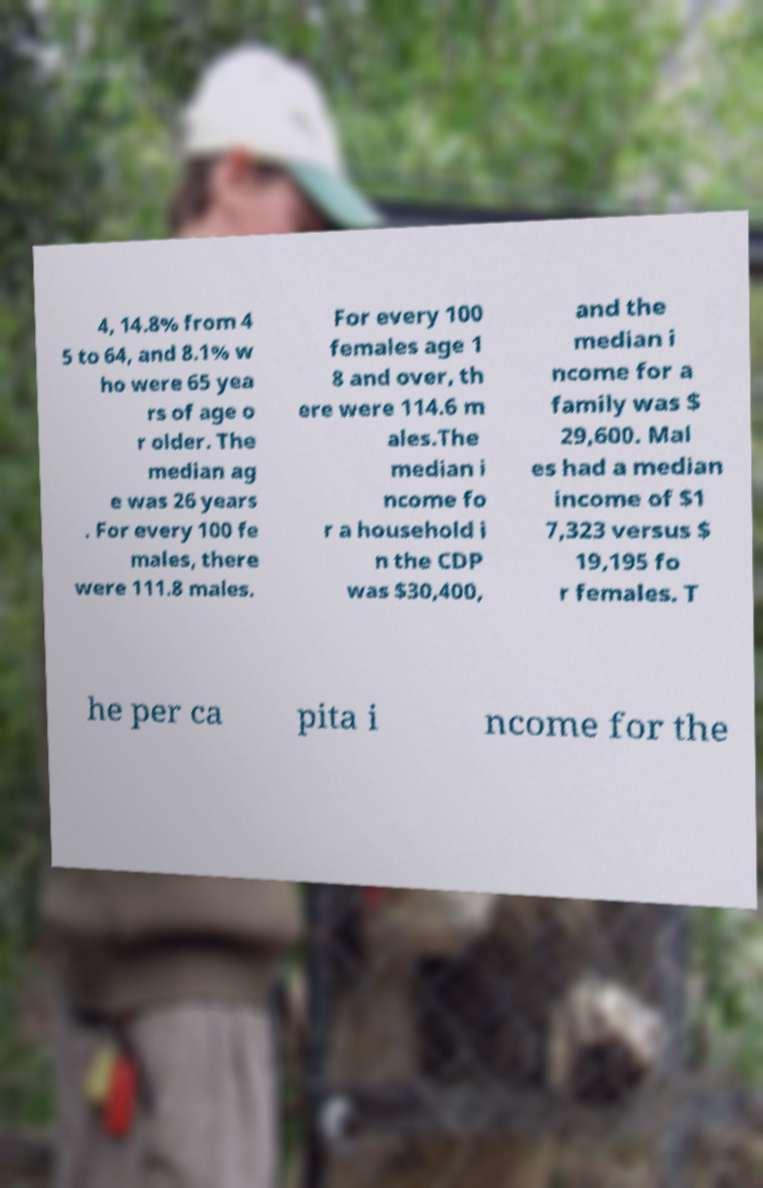Can you accurately transcribe the text from the provided image for me? 4, 14.8% from 4 5 to 64, and 8.1% w ho were 65 yea rs of age o r older. The median ag e was 26 years . For every 100 fe males, there were 111.8 males. For every 100 females age 1 8 and over, th ere were 114.6 m ales.The median i ncome fo r a household i n the CDP was $30,400, and the median i ncome for a family was $ 29,600. Mal es had a median income of $1 7,323 versus $ 19,195 fo r females. T he per ca pita i ncome for the 